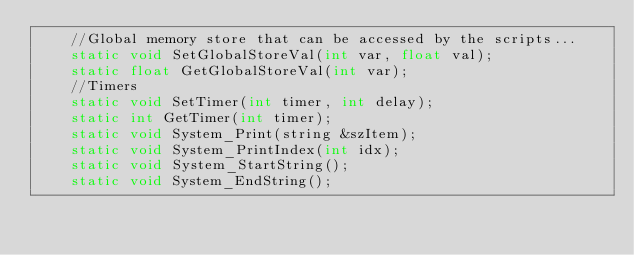<code> <loc_0><loc_0><loc_500><loc_500><_C_>	//Global memory store that can be accessed by the scripts...
	static void SetGlobalStoreVal(int var, float val);
	static float GetGlobalStoreVal(int var);
	//Timers
	static void SetTimer(int timer, int delay);
	static int GetTimer(int timer);
	static void System_Print(string &szItem);
	static void System_PrintIndex(int idx);
	static void System_StartString();
	static void System_EndString();</code> 